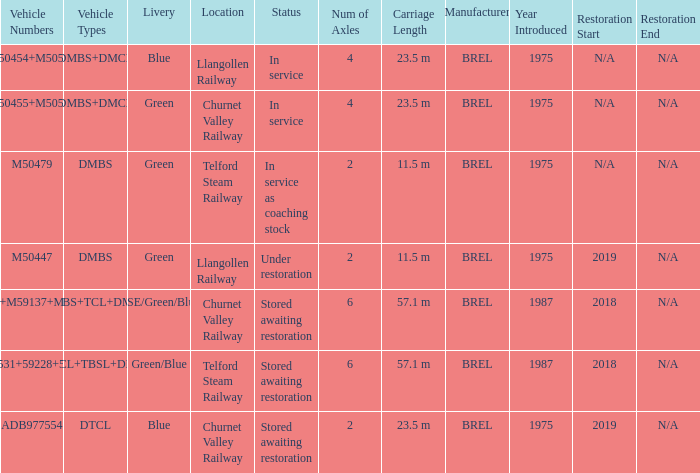What status is the vehicle types of dmbs+tcl+dmcl? Stored awaiting restoration. 